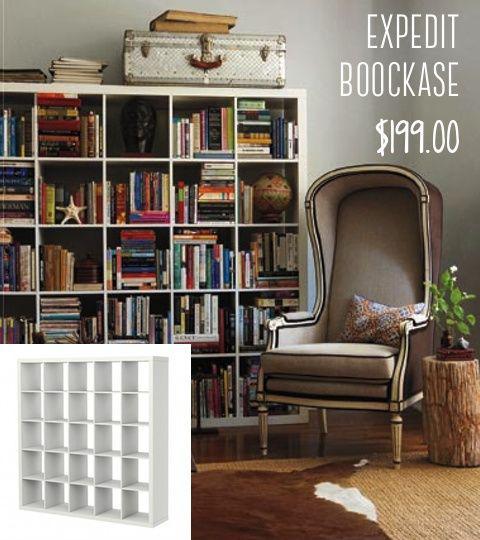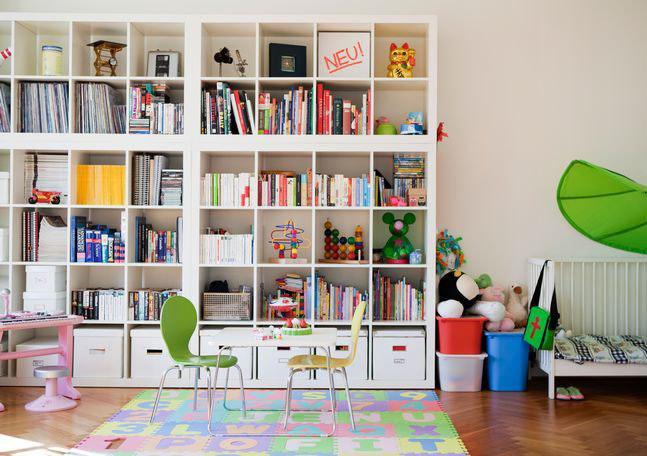The first image is the image on the left, the second image is the image on the right. Evaluate the accuracy of this statement regarding the images: "there is a white bookshelf with a mirror hanging on it". Is it true? Answer yes or no. No. The first image is the image on the left, the second image is the image on the right. Assess this claim about the two images: "The wall-filling white shelf unit in the left image features multiple red squares.". Correct or not? Answer yes or no. No. 